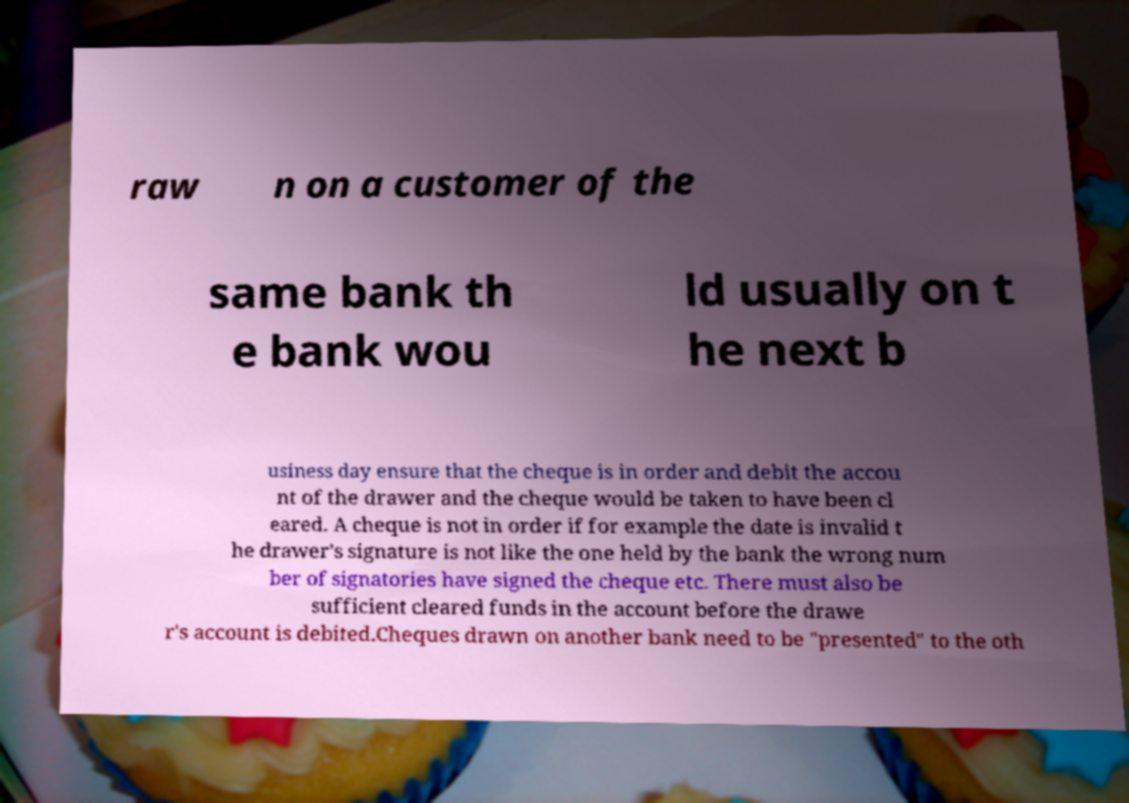Please identify and transcribe the text found in this image. raw n on a customer of the same bank th e bank wou ld usually on t he next b usiness day ensure that the cheque is in order and debit the accou nt of the drawer and the cheque would be taken to have been cl eared. A cheque is not in order if for example the date is invalid t he drawer's signature is not like the one held by the bank the wrong num ber of signatories have signed the cheque etc. There must also be sufficient cleared funds in the account before the drawe r's account is debited.Cheques drawn on another bank need to be "presented" to the oth 